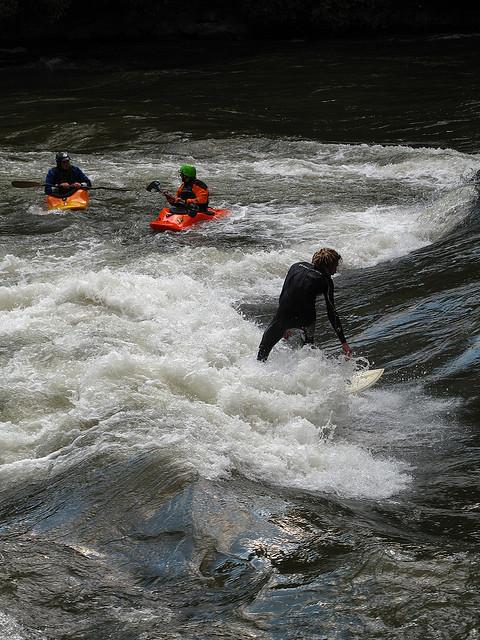What is the person to the far left sitting on?

Choices:
A) bench
B) chair
C) cardboard box
D) boat boat 